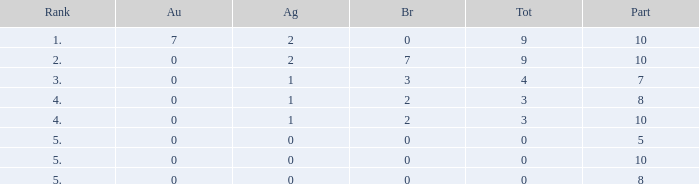What is identified as the maximum gold with a silver below 1 and a total under 0? None. 